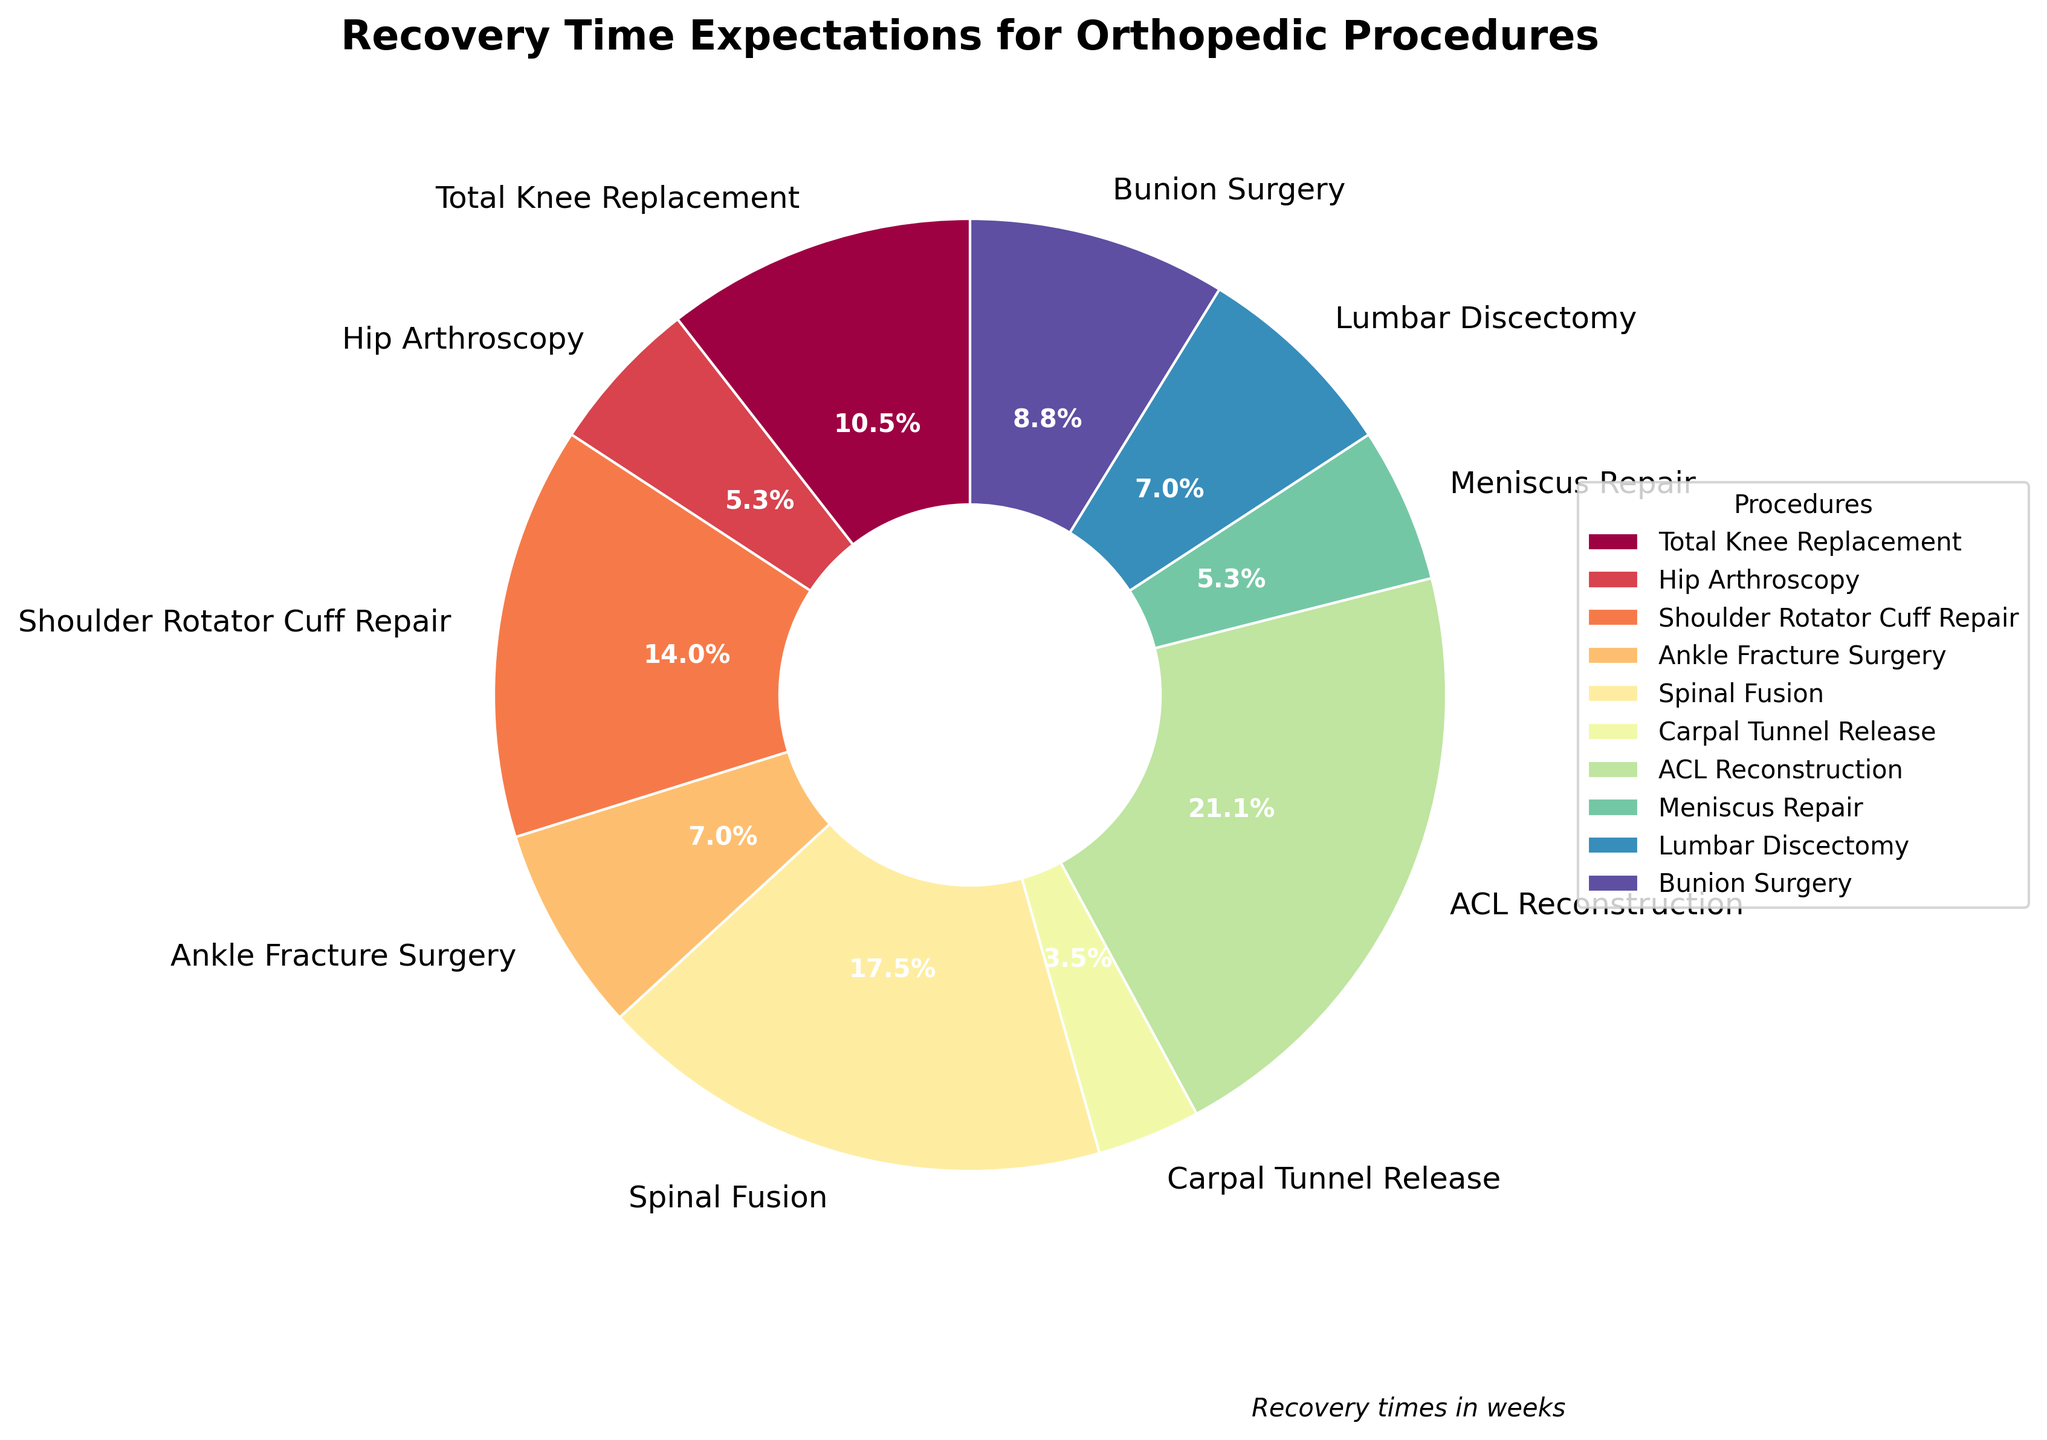What's the procedure with the longest recovery time? Look at the pie chart and find the label with the largest portion, which represents 24 weeks for ACL Reconstruction.
Answer: ACL Reconstruction What's the total recovery time for Hip Arthroscopy and Meniscus Repair combined? Hip Arthroscopy has a recovery time of 6 weeks and Meniscus Repair also has 6 weeks. Sum them up: 6 + 6 = 12 weeks.
Answer: 12 weeks Which procedure has a shorter recovery time: Bunion Surgery or Spinal Fusion? Compare the recovery times from the pie chart: Bunion Surgery has 10 weeks and Spinal Fusion has 20 weeks.
Answer: Bunion Surgery What percentage of the total recovery time is attributed to Carpal Tunnel Release? Carpal Tunnel Release has a recovery time of 4 weeks. The total recovery time for all procedures is 114 weeks. The percentage is calculated as (4 / 114) * 100 ≈ 3.5%.
Answer: 3.5% How much longer is the recovery time for ACL Reconstruction compared to Carpal Tunnel Release? ACL Reconstruction has a recovery time of 24 weeks and Carpal Tunnel Release is 4 weeks. The difference is 24 - 4 = 20 weeks.
Answer: 20 weeks What's the average recovery time for the procedures listed? Sum all the recovery times: 12 + 6 + 16 + 8 + 20 + 4 + 24 + 6 + 8 + 10 = 114 weeks. There are 10 procedures, so the average recovery time is 114 / 10 = 11.4 weeks.
Answer: 11.4 weeks Which procedure has a larger recovery time: Shoulder Rotator Cuff Repair or Lumbar Discectomy? Compare the recovery times from the pie chart: Shoulder Rotator Cuff Repair has 16 weeks and Lumbar Discectomy has 8 weeks.
Answer: Shoulder Rotator Cuff Repair How many procedures have a recovery time shorter than 10 weeks? From the pie chart, Carpal Tunnel Release (4 weeks), Hip Arthroscopy (6 weeks), Meniscus Repair (6 weeks), Lumbar Discectomy (8 weeks), and Ankle Fracture Surgery (8 weeks) all have recovery times shorter than 10 weeks. There are 5 such procedures.
Answer: 5 What color represents Spinal Fusion, and how can you find it in the pie chart? Find Spinal Fusion in the legend of the pie chart and match the color next to it to the corresponding segment in the pie chart. Spinal Fusion is represented by a specific slice and color combination.
Answer: [Mimic answer based on expected palette but should be a specific color like dark red or similar] Would the total percentage of procedures with a recovery time of 8 weeks or less be higher or lower than 50%? Identify the procedures with recovery times of 8 weeks or less: Carpal Tunnel Release (4 weeks), Hip Arthroscopy (6 weeks), Ankle Fracture Surgery (8 weeks), Meniscus Repair (6 weeks), and Lumbar Discectomy (8 weeks). These account for 5 out of 10 procedures, so 50%. Sum their percentages and compare against 50%.
Answer: Equal to 50% 